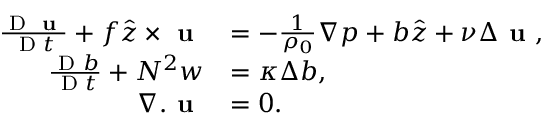Convert formula to latex. <formula><loc_0><loc_0><loc_500><loc_500>\begin{array} { r l } { \frac { D u } { D t } + f \hat { z } \times u } & { = - \frac { 1 } { \rho _ { 0 } } \nabla p + b \hat { z } + \nu \Delta u , } \\ { \frac { D b } { D t } + N ^ { 2 } w } & { = \kappa \Delta b , } \\ { \nabla . u } & { = 0 . } \end{array}</formula> 